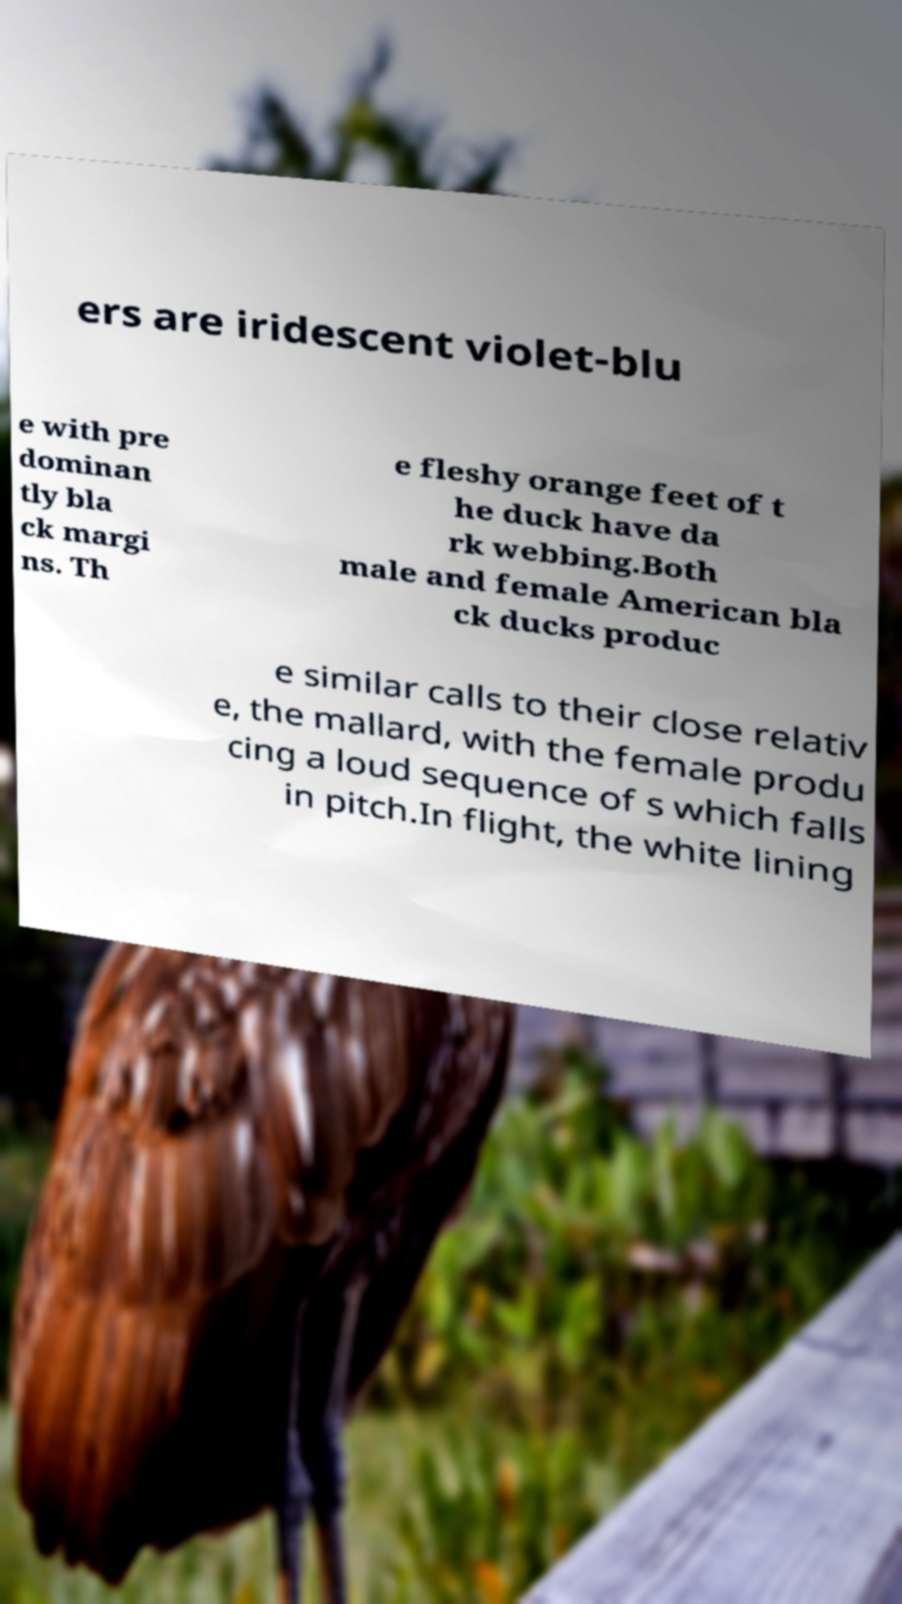Please identify and transcribe the text found in this image. ers are iridescent violet-blu e with pre dominan tly bla ck margi ns. Th e fleshy orange feet of t he duck have da rk webbing.Both male and female American bla ck ducks produc e similar calls to their close relativ e, the mallard, with the female produ cing a loud sequence of s which falls in pitch.In flight, the white lining 